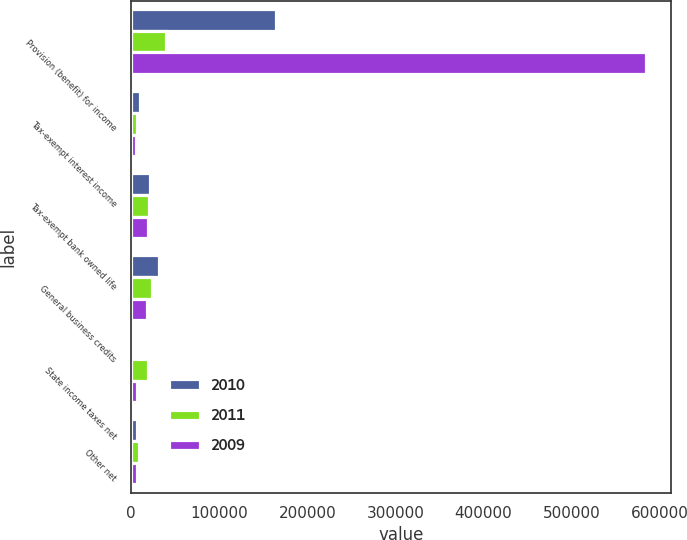Convert chart. <chart><loc_0><loc_0><loc_500><loc_500><stacked_bar_chart><ecel><fcel>Provision (benefit) for income<fcel>Tax-exempt interest income<fcel>Tax-exempt bank owned life<fcel>General business credits<fcel>State income taxes net<fcel>Other net<nl><fcel>2010<fcel>164621<fcel>9695<fcel>21169<fcel>31269<fcel>2962<fcel>6928<nl><fcel>2011<fcel>39964<fcel>6680<fcel>20595<fcel>23360<fcel>19196<fcel>9163<nl><fcel>2009<fcel>584004<fcel>5561<fcel>19205<fcel>17602<fcel>6842<fcel>6544<nl></chart> 